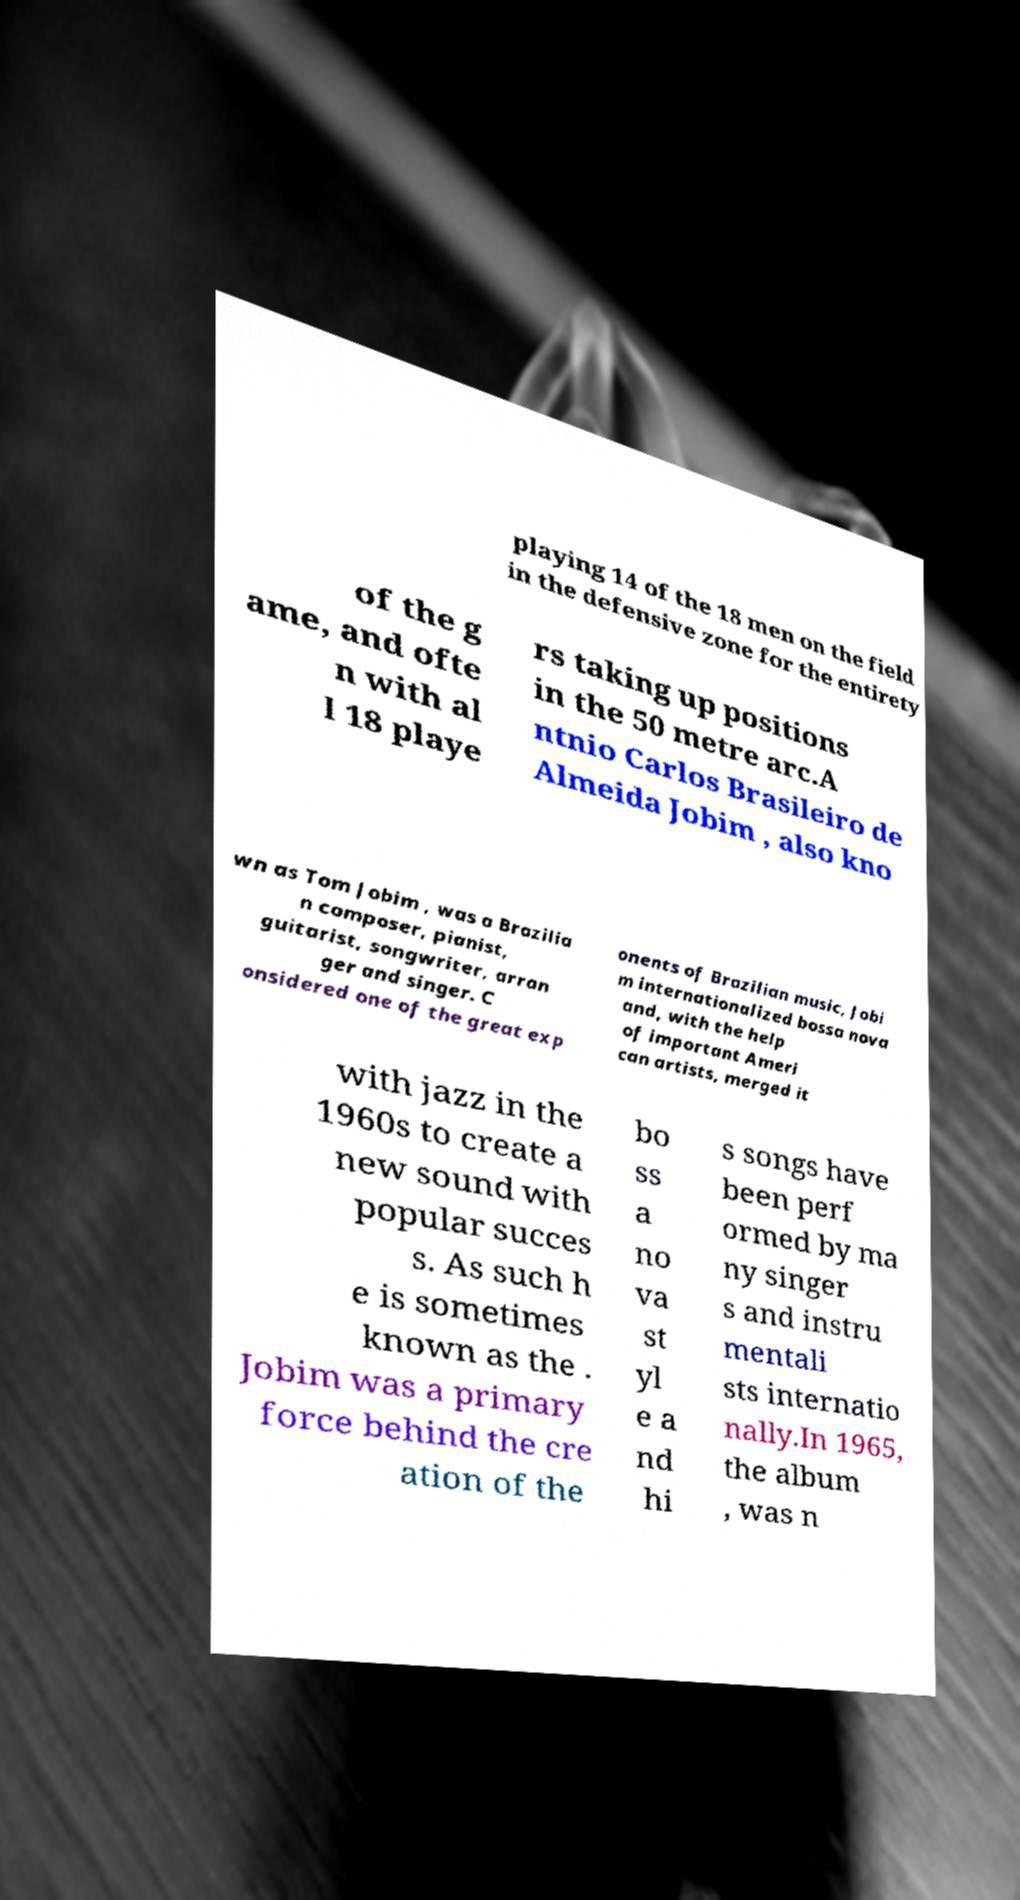Can you read and provide the text displayed in the image?This photo seems to have some interesting text. Can you extract and type it out for me? playing 14 of the 18 men on the field in the defensive zone for the entirety of the g ame, and ofte n with al l 18 playe rs taking up positions in the 50 metre arc.A ntnio Carlos Brasileiro de Almeida Jobim , also kno wn as Tom Jobim , was a Brazilia n composer, pianist, guitarist, songwriter, arran ger and singer. C onsidered one of the great exp onents of Brazilian music, Jobi m internationalized bossa nova and, with the help of important Ameri can artists, merged it with jazz in the 1960s to create a new sound with popular succes s. As such h e is sometimes known as the . Jobim was a primary force behind the cre ation of the bo ss a no va st yl e a nd hi s songs have been perf ormed by ma ny singer s and instru mentali sts internatio nally.In 1965, the album , was n 